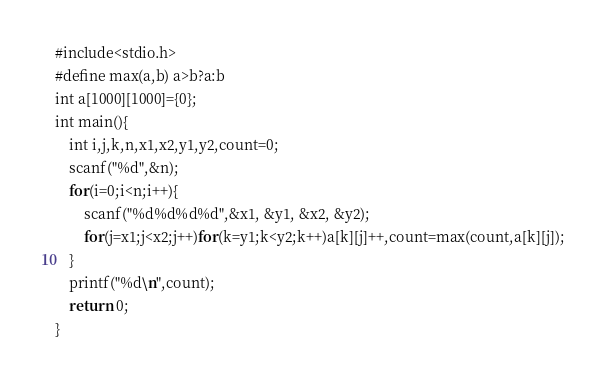Convert code to text. <code><loc_0><loc_0><loc_500><loc_500><_C_>#include<stdio.h>
#define max(a,b) a>b?a:b
int a[1000][1000]={0};
int main(){
    int i,j,k,n,x1,x2,y1,y2,count=0;
    scanf("%d",&n);
    for(i=0;i<n;i++){
        scanf("%d%d%d%d",&x1, &y1, &x2, &y2);
        for(j=x1;j<x2;j++)for(k=y1;k<y2;k++)a[k][j]++,count=max(count,a[k][j]); 
    }
    printf("%d\n",count);
    return 0;
}</code> 